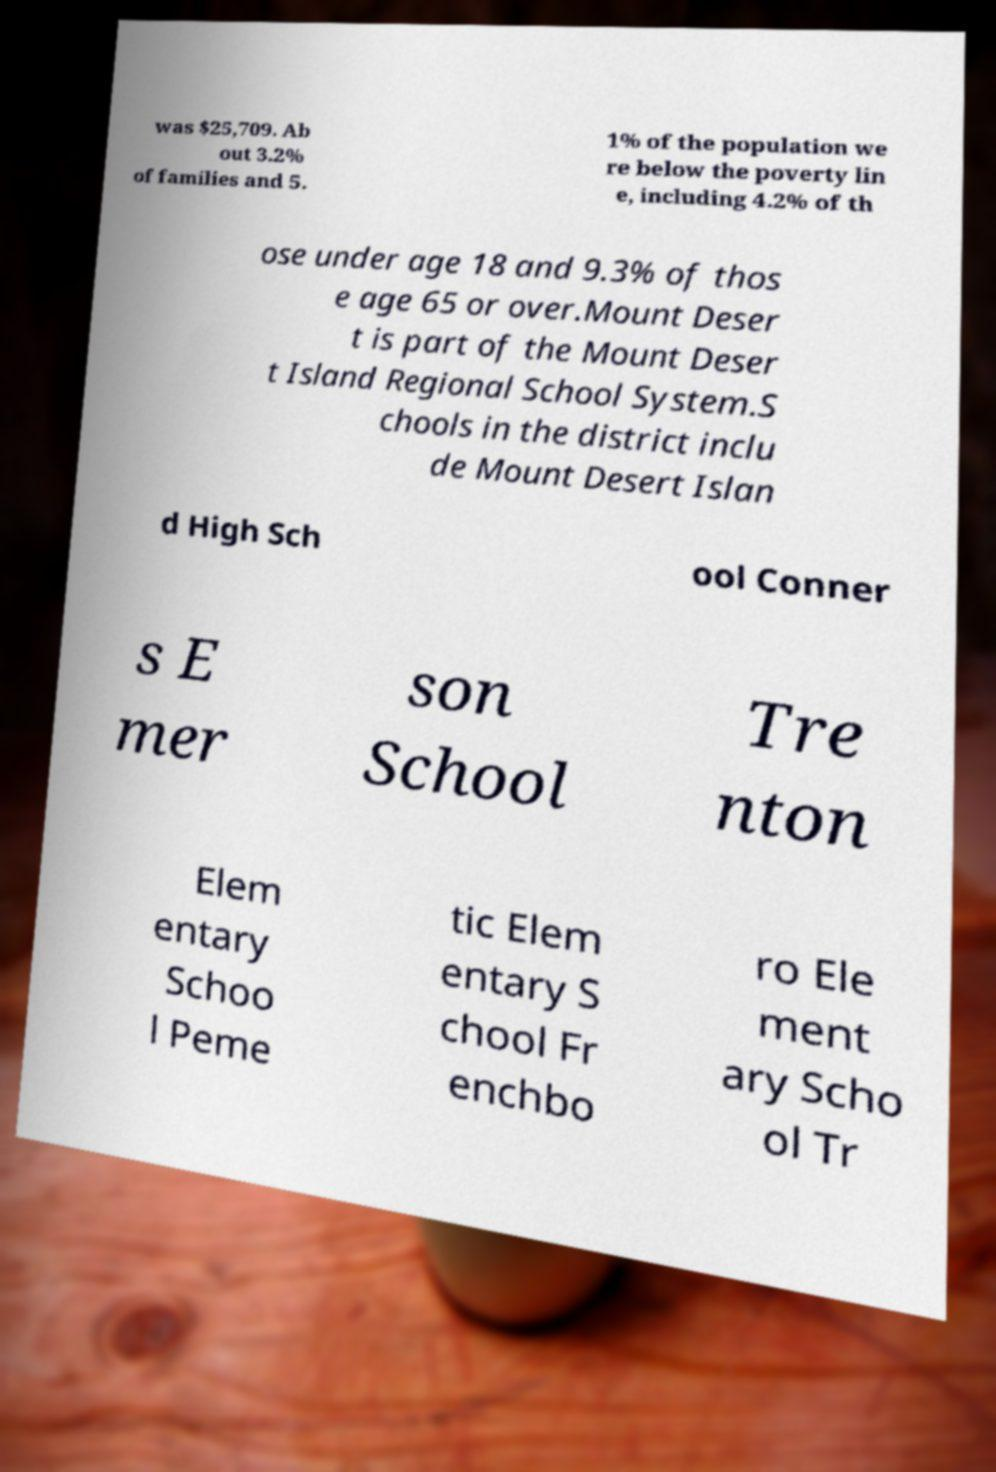What messages or text are displayed in this image? I need them in a readable, typed format. was $25,709. Ab out 3.2% of families and 5. 1% of the population we re below the poverty lin e, including 4.2% of th ose under age 18 and 9.3% of thos e age 65 or over.Mount Deser t is part of the Mount Deser t Island Regional School System.S chools in the district inclu de Mount Desert Islan d High Sch ool Conner s E mer son School Tre nton Elem entary Schoo l Peme tic Elem entary S chool Fr enchbo ro Ele ment ary Scho ol Tr 